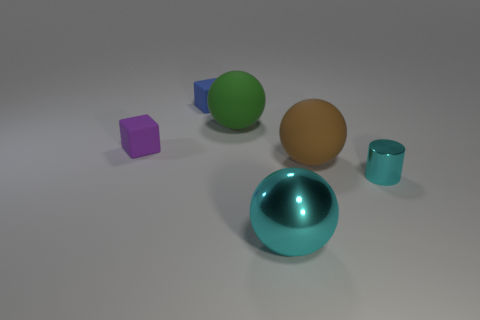There is a thing that is both in front of the purple block and behind the metallic cylinder; how big is it?
Your answer should be compact. Large. There is a cyan object right of the metallic thing that is in front of the small thing to the right of the brown sphere; what is its size?
Provide a succinct answer. Small. There is a small blue rubber block; are there any cubes in front of it?
Your response must be concise. Yes. There is a purple block; is it the same size as the matte thing that is on the right side of the big green rubber thing?
Offer a terse response. No. How many other objects are there of the same material as the brown object?
Keep it short and to the point. 3. The thing that is left of the tiny cyan cylinder and in front of the brown rubber object has what shape?
Your answer should be compact. Sphere. There is a cyan shiny object in front of the tiny metal cylinder; is it the same size as the matte ball that is behind the tiny purple cube?
Provide a succinct answer. Yes. The blue object that is the same material as the brown ball is what shape?
Give a very brief answer. Cube. Is there any other thing that has the same shape as the brown thing?
Offer a very short reply. Yes. What is the color of the shiny thing left of the small object that is to the right of the big rubber thing that is in front of the tiny purple rubber thing?
Offer a terse response. Cyan. 